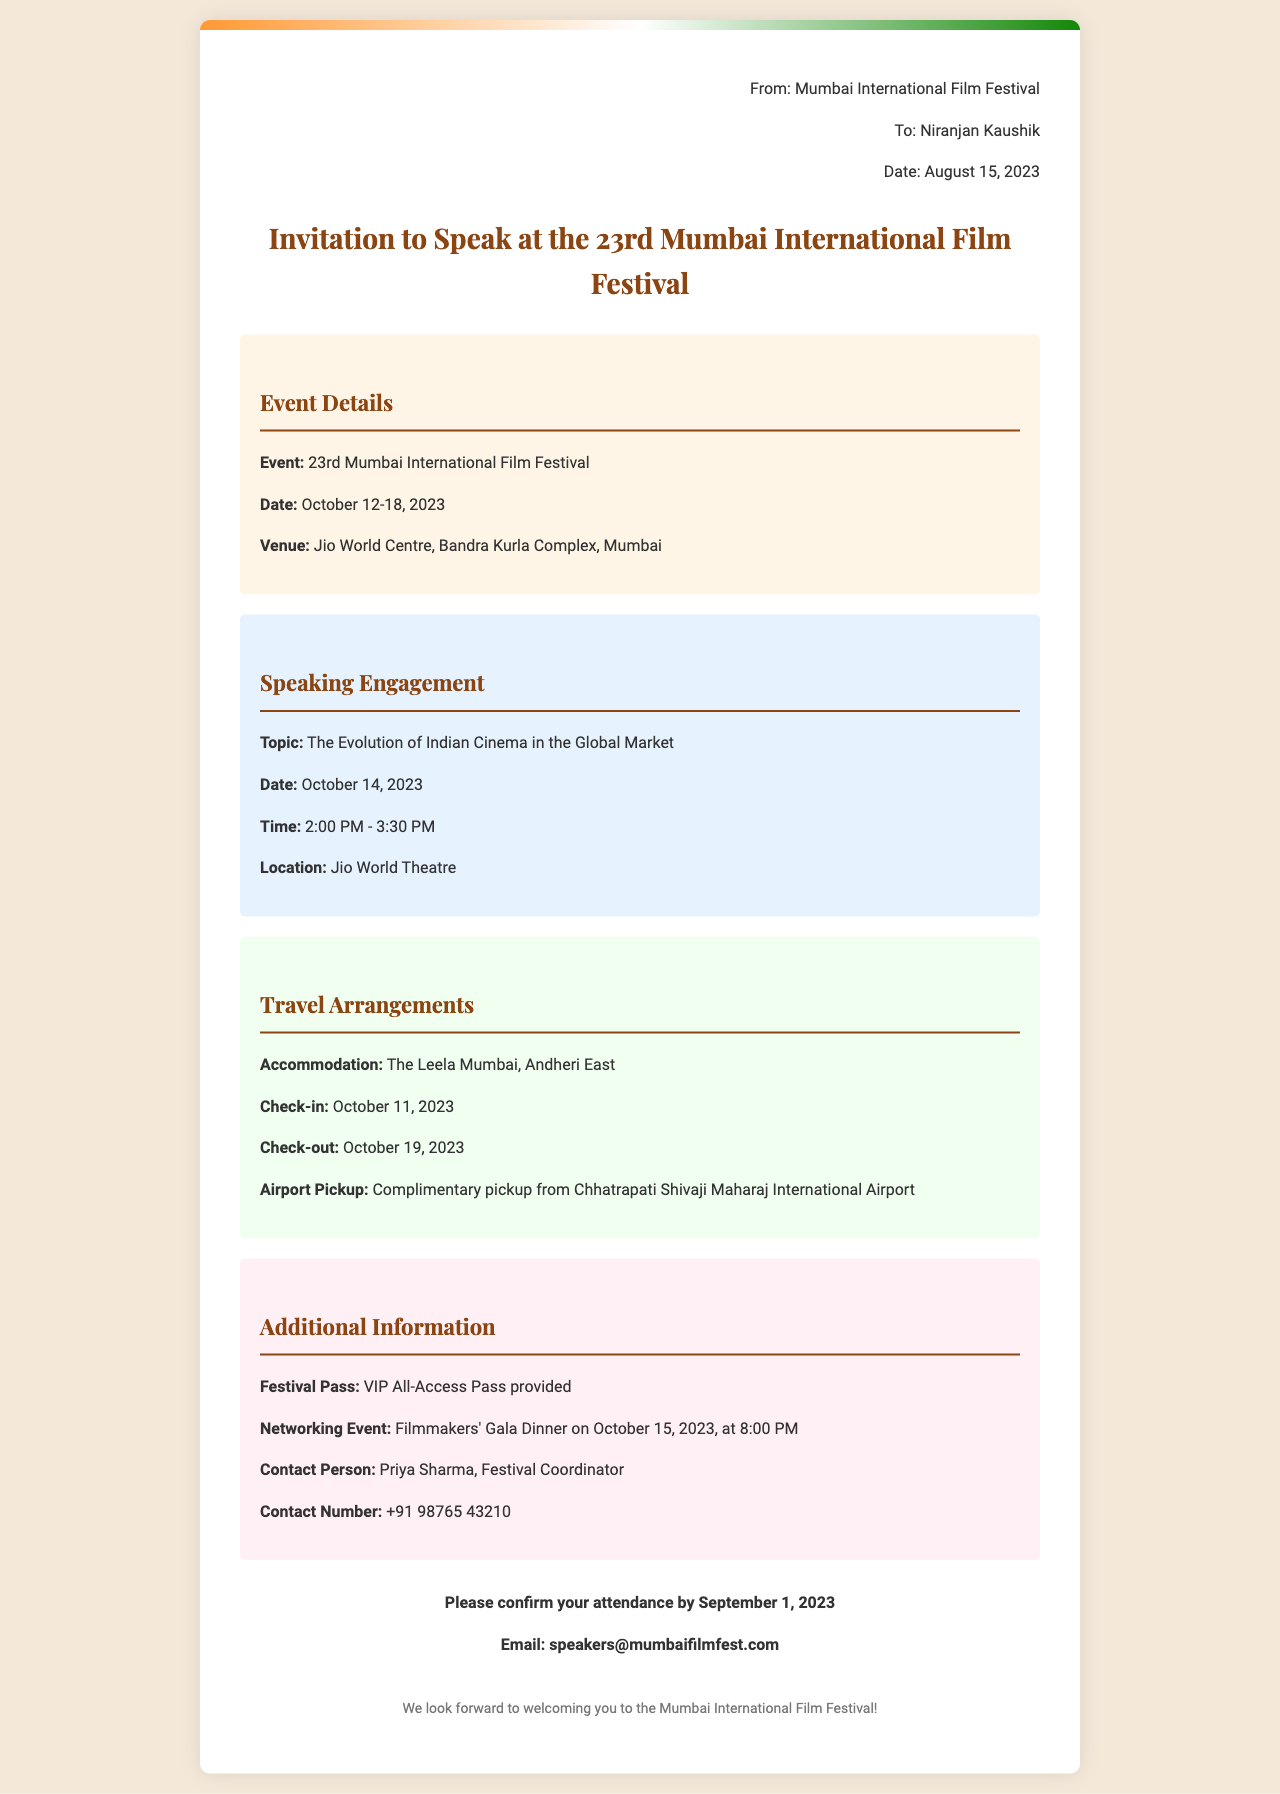what is the event date? The event date is provided in the invitation details section, specifically stating October 12-18, 2023.
Answer: October 12-18, 2023 what is the speaking engagement topic? The speaking engagement topic is mentioned in the speaking engagement section, which is "The Evolution of Indian Cinema in the Global Market."
Answer: The Evolution of Indian Cinema in the Global Market where is the venue located? The venue is given in the invitation details section as Jio World Centre, Bandra Kurla Complex, Mumbai.
Answer: Jio World Centre, Bandra Kurla Complex, Mumbai who should be contacted for more information? The contact person is noted in the additional information section, which is Priya Sharma, the Festival Coordinator.
Answer: Priya Sharma what time is the speaking engagement? The speaking engagement time is specified in the speaking engagement section as 2:00 PM - 3:30 PM on October 14, 2023.
Answer: 2:00 PM - 3:30 PM what is the accommodation provided? The accommodation details are in the travel arrangements section, which states The Leela Mumbai, Andheri East.
Answer: The Leela Mumbai, Andheri East what is the check-out date? The check-out date is noted in the travel arrangements section, which is October 19, 2023.
Answer: October 19, 2023 what is the last date to confirm attendance? The response required section indicates that the last date to confirm attendance is September 1, 2023.
Answer: September 1, 2023 what type of festival pass is provided? The type of festival pass is mentioned in the additional information section as a VIP All-Access Pass.
Answer: VIP All-Access Pass 